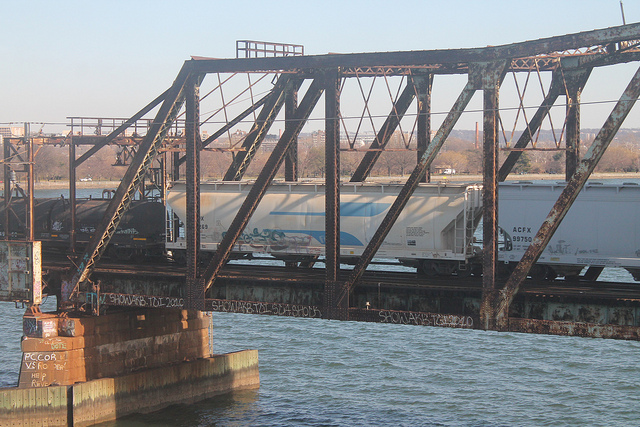Read and extract the text from this image. PCCOR 